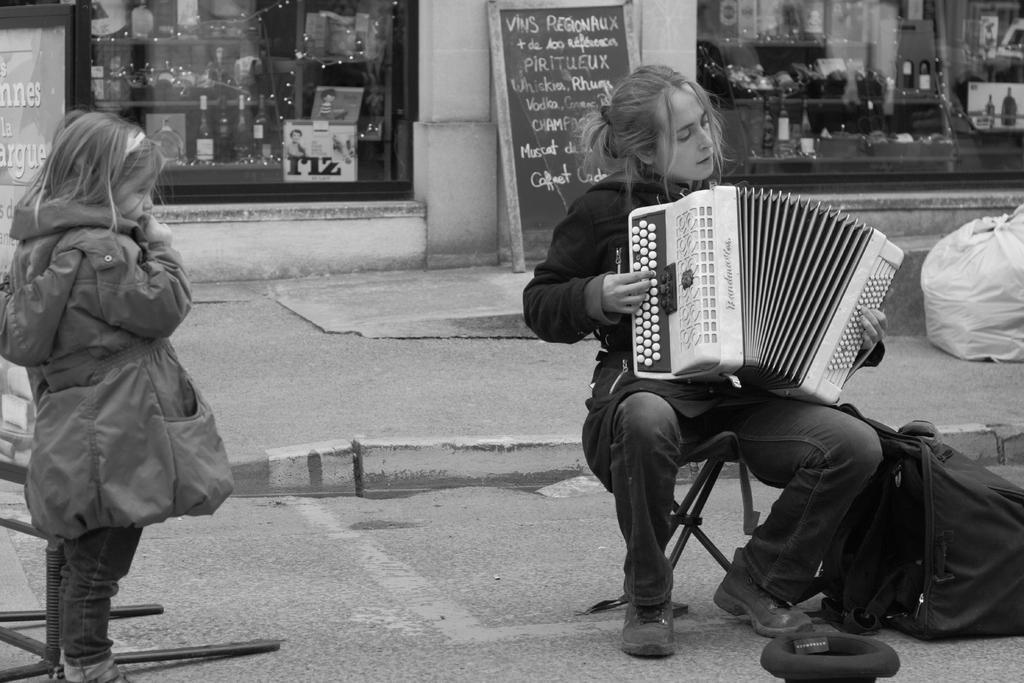Please provide a concise description of this image. In the picture we can see a woman sitting on the stool and playing a musical instrument and beside her we can see a girl child standing and watching her and in the background, we can see a shop with glass wall from it, we can see some items with lights and outside the shop we can see a board with something written on it. 